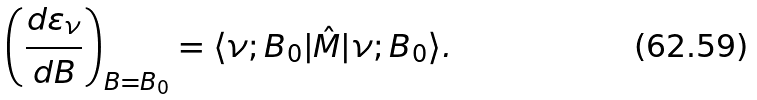Convert formula to latex. <formula><loc_0><loc_0><loc_500><loc_500>\left ( \frac { d \varepsilon _ { \nu } } { d B } \right ) _ { B = B _ { 0 } } = \langle \nu ; B _ { 0 } | \hat { M } | \nu ; B _ { 0 } \rangle .</formula> 